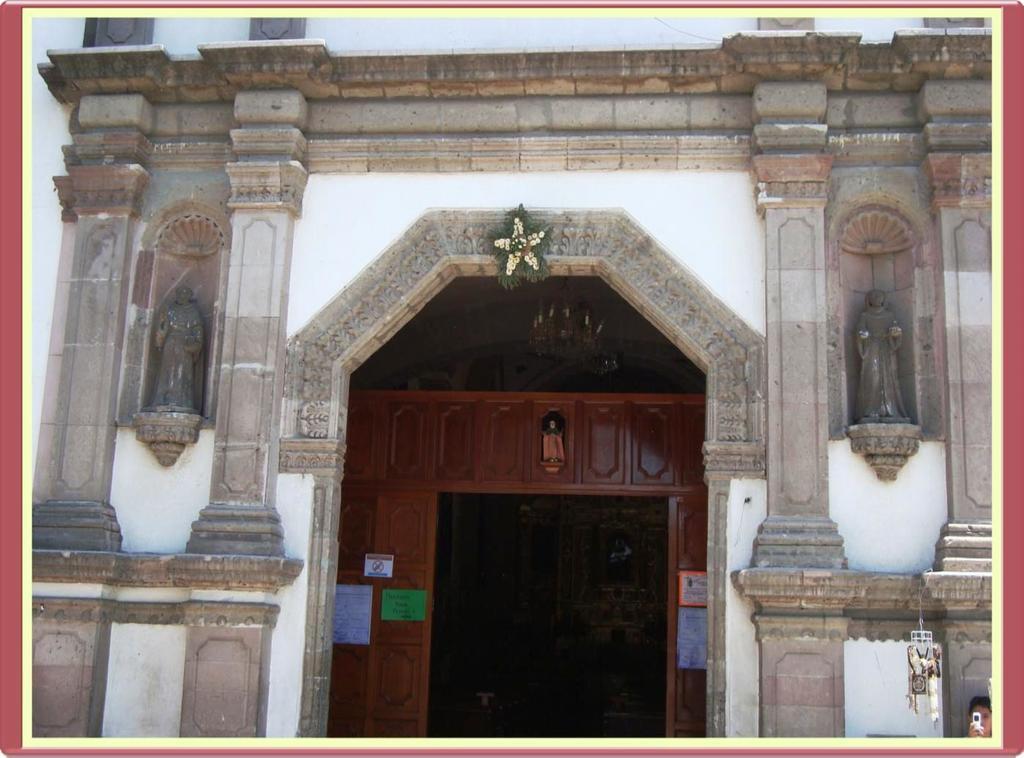In one or two sentences, can you explain what this image depicts? In this image, we can see some pillars, at the middle there is a door. 